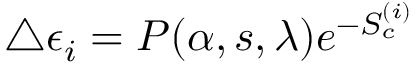<formula> <loc_0><loc_0><loc_500><loc_500>\triangle \epsilon _ { i } = P ( \alpha , s , \lambda ) e ^ { - S _ { c } ^ { ( i ) } }</formula> 